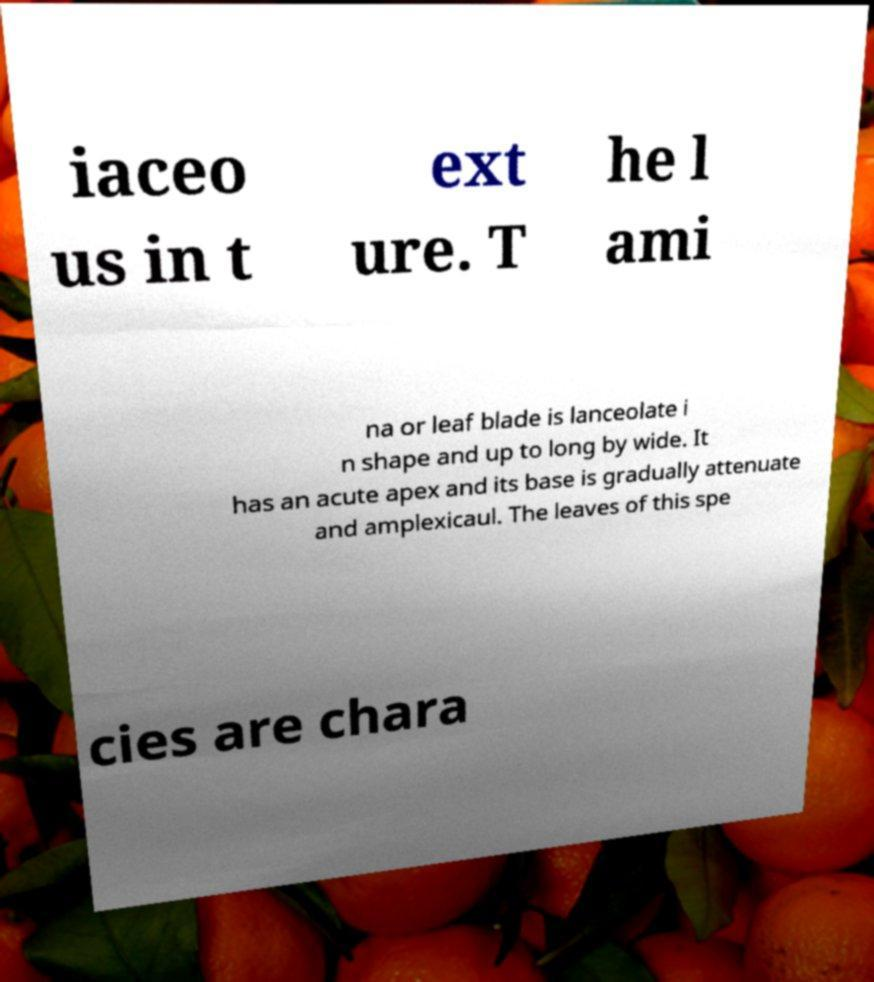Could you extract and type out the text from this image? iaceo us in t ext ure. T he l ami na or leaf blade is lanceolate i n shape and up to long by wide. It has an acute apex and its base is gradually attenuate and amplexicaul. The leaves of this spe cies are chara 